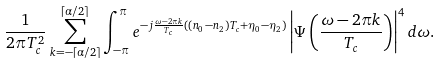<formula> <loc_0><loc_0><loc_500><loc_500>\frac { 1 } { 2 \pi T _ { c } ^ { 2 } } \sum _ { k = - \lceil \alpha / 2 \rceil } ^ { \lceil \alpha / 2 \rceil } \int _ { - \pi } ^ { \pi } e ^ { - j \frac { \omega - 2 \pi k } { T _ { c } } ( ( n _ { 0 } - n _ { 2 } ) T _ { c } + \eta _ { 0 } - \eta _ { 2 } ) } \left | \Psi \left ( \frac { \omega - 2 \pi k } { T _ { c } } \right ) \right | ^ { 4 } d \omega .</formula> 